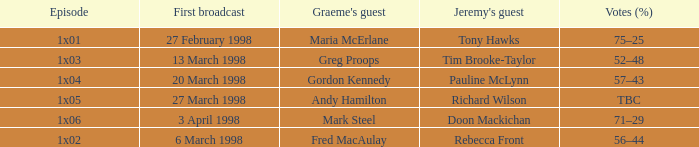What is Votes (%), when First Broadcast is "13 March 1998"? 52–48. 